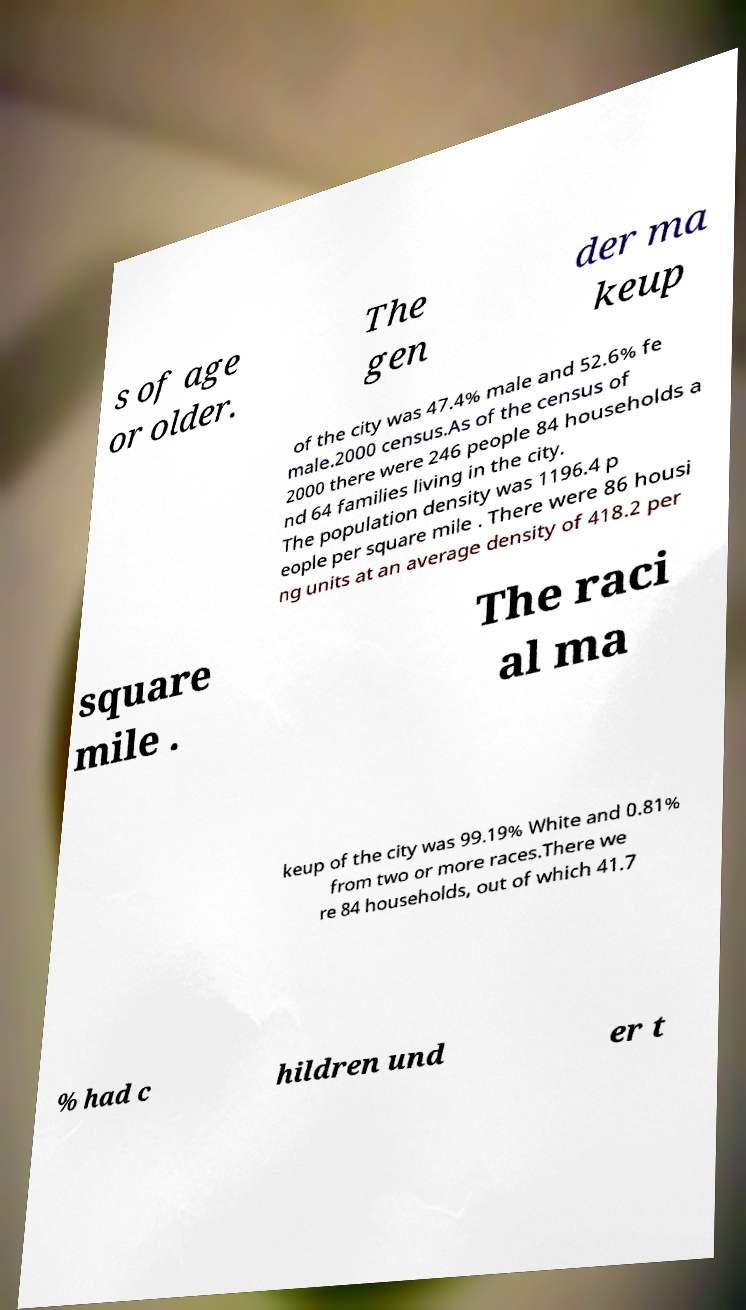For documentation purposes, I need the text within this image transcribed. Could you provide that? s of age or older. The gen der ma keup of the city was 47.4% male and 52.6% fe male.2000 census.As of the census of 2000 there were 246 people 84 households a nd 64 families living in the city. The population density was 1196.4 p eople per square mile . There were 86 housi ng units at an average density of 418.2 per square mile . The raci al ma keup of the city was 99.19% White and 0.81% from two or more races.There we re 84 households, out of which 41.7 % had c hildren und er t 